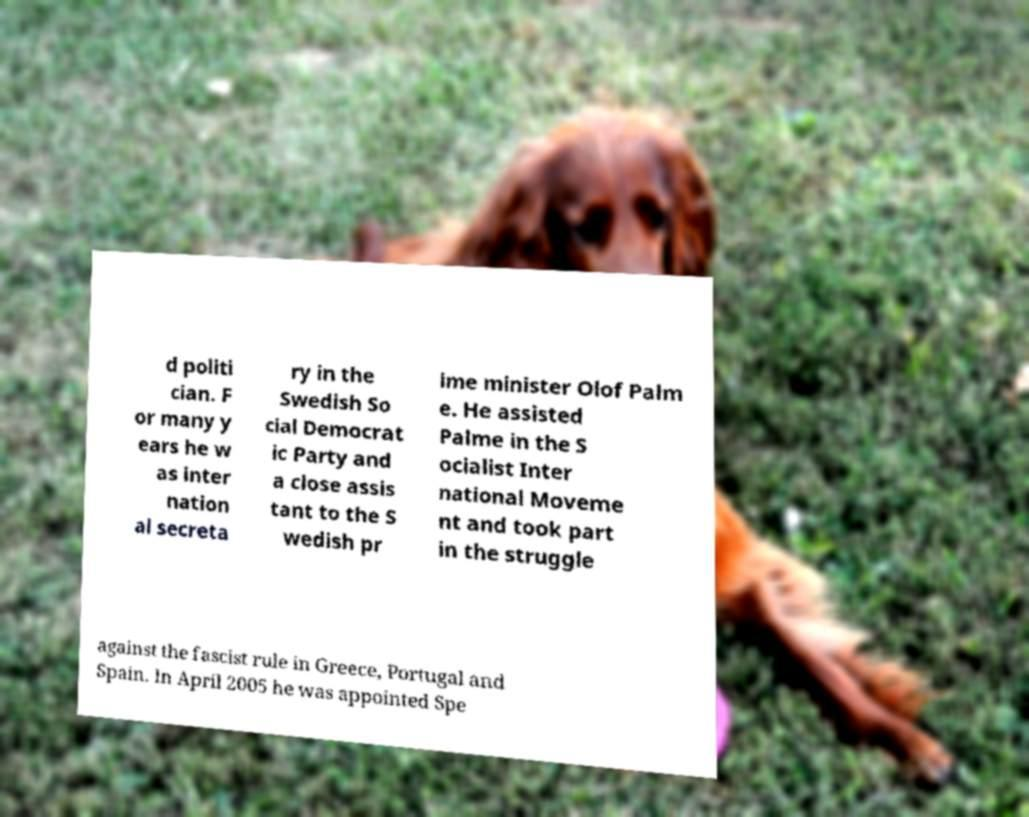I need the written content from this picture converted into text. Can you do that? d politi cian. F or many y ears he w as inter nation al secreta ry in the Swedish So cial Democrat ic Party and a close assis tant to the S wedish pr ime minister Olof Palm e. He assisted Palme in the S ocialist Inter national Moveme nt and took part in the struggle against the fascist rule in Greece, Portugal and Spain. In April 2005 he was appointed Spe 